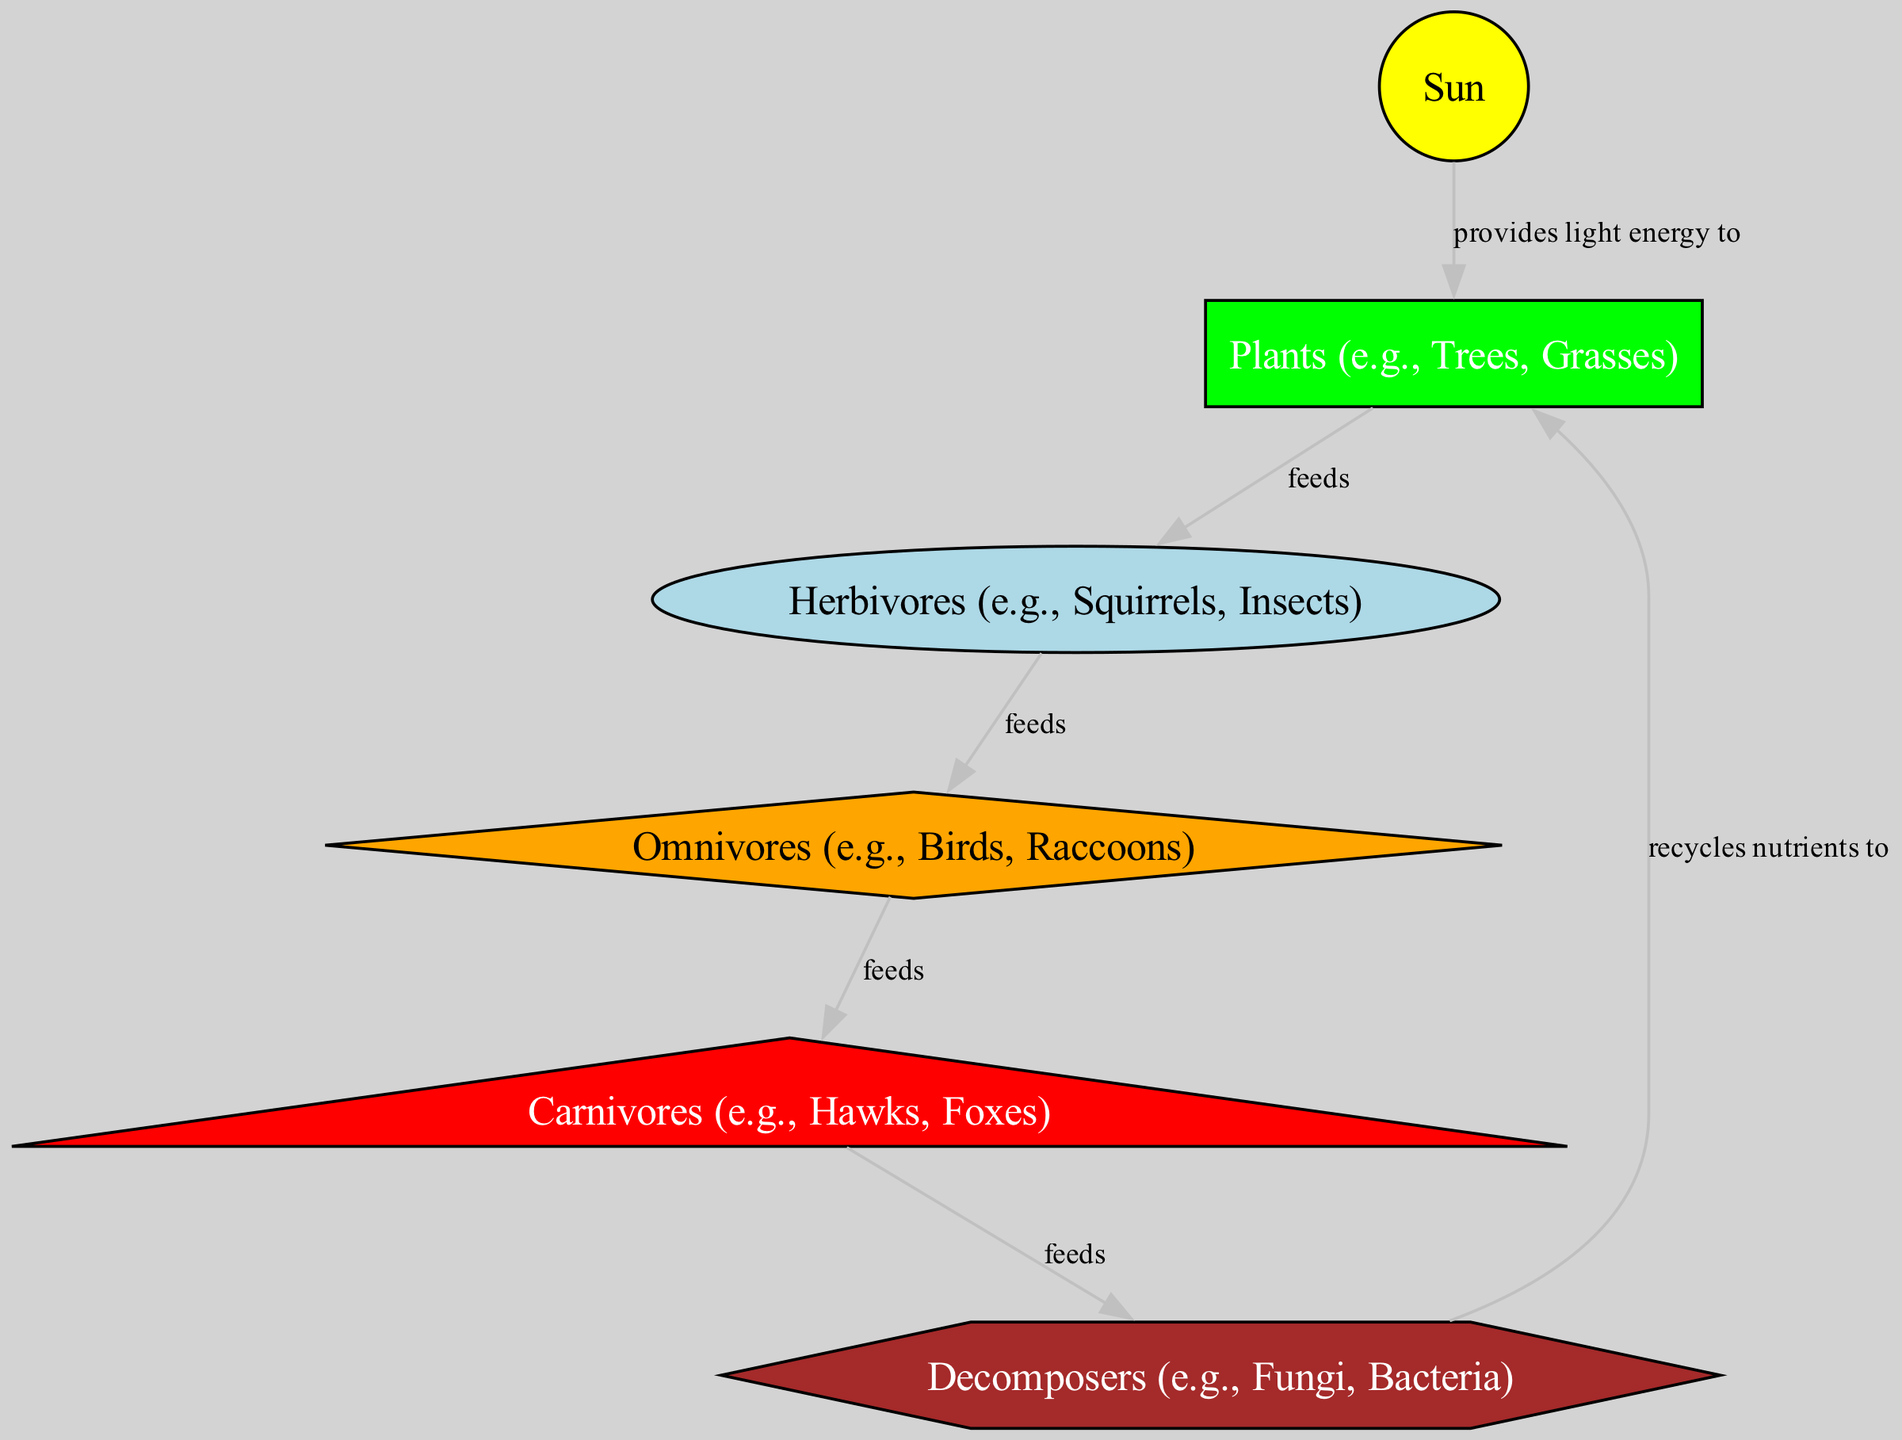What is the primary energy source for the food chain? The sun is the primary energy source depicted in the diagram, as indicated by the node labeled "Sun." It is the first node and provides light energy to the plants.
Answer: Sun How many nodes are present in the diagram? The diagram shows six distinct nodes: Sun, Plants, Herbivores, Omnivores, Carnivores, and Decomposers. Counting these gives a total of six nodes.
Answer: 6 What do herbivores feed on? According to the diagram, herbivores feed on plants, which is shown by the edge connecting the "Plants" node to the "Herbivores" node labeled "feeds."
Answer: Plants Which group feeds on omnivores? The diagram shows that carnivores feed on omnivores, as indicated by the edge connecting the "Omnivores" node to the "Carnivores" node with the label "feeds."
Answer: Carnivores What is the relationship between decomposers and plants? The relationship indicated in the diagram shows that decomposers recycle nutrients to plants, as seen in the edge connecting the "Decomposers" node back to the "Plants" node.
Answer: Recycles nutrients to How many feeding relationships are represented in the diagram? The diagram has five feeding relationships represented by the edges that illustrate the flow of energy from one group to another: Sun to Plants, Plants to Herbivores, Herbivores to Omnivores, Omnivores to Carnivores, and Carnivores to Decomposers. Adding these gives a total of five feeding relationships.
Answer: 5 Which organisms serve as primary producers in the diagram? The primary producers in the diagram are represented by plants, as they are the first group to receive energy from the sun and produce food.
Answer: Plants What role do decomposers play in the food chain? Decomposers are crucial in the food chain as they recycle nutrients back to the plants in the ecosystem, completing the cycle of energy flow as shown in the diagram.
Answer: Recycle nutrients 